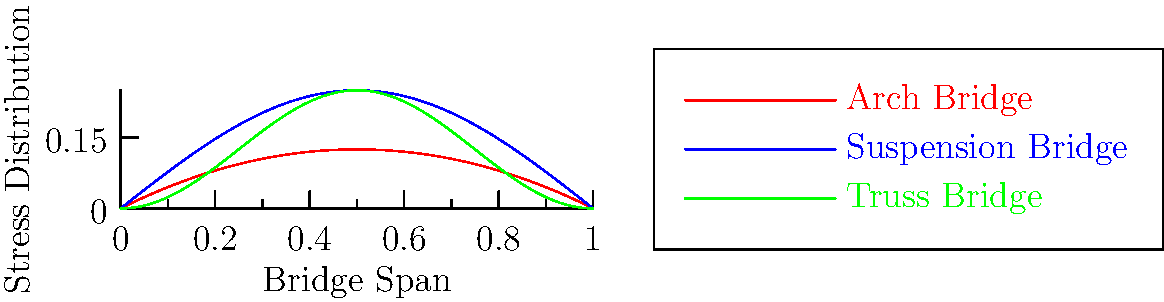During our bridge design discussion at the senior social club, we examined stress distributions in different bridge types. Based on the graph, which bridge design appears to have the most uniform stress distribution across its span? Let's analyze the stress distribution for each bridge type step-by-step:

1. Arch Bridge (red curve):
   - Starts and ends at zero stress
   - Peaks at the center with maximum stress
   - Shows a parabolic distribution

2. Suspension Bridge (blue curve):
   - Has alternating high and low stress points
   - Shows a sinusoidal distribution
   - Stress varies significantly across the span

3. Truss Bridge (green curve):
   - Starts and ends with low stress
   - Has a more gradual increase and decrease in stress
   - Shows a cosine-based distribution

The most uniform stress distribution would be the one with the least variation across the span. The Truss Bridge (green curve) demonstrates this characteristic, as it has a more gradual change in stress levels and less extreme peaks and valleys compared to the other designs.

The Arch Bridge has a significant concentration of stress in the center, while the Suspension Bridge has multiple high-stress points. In contrast, the Truss Bridge distributes the stress more evenly across its entire span.
Answer: Truss Bridge 